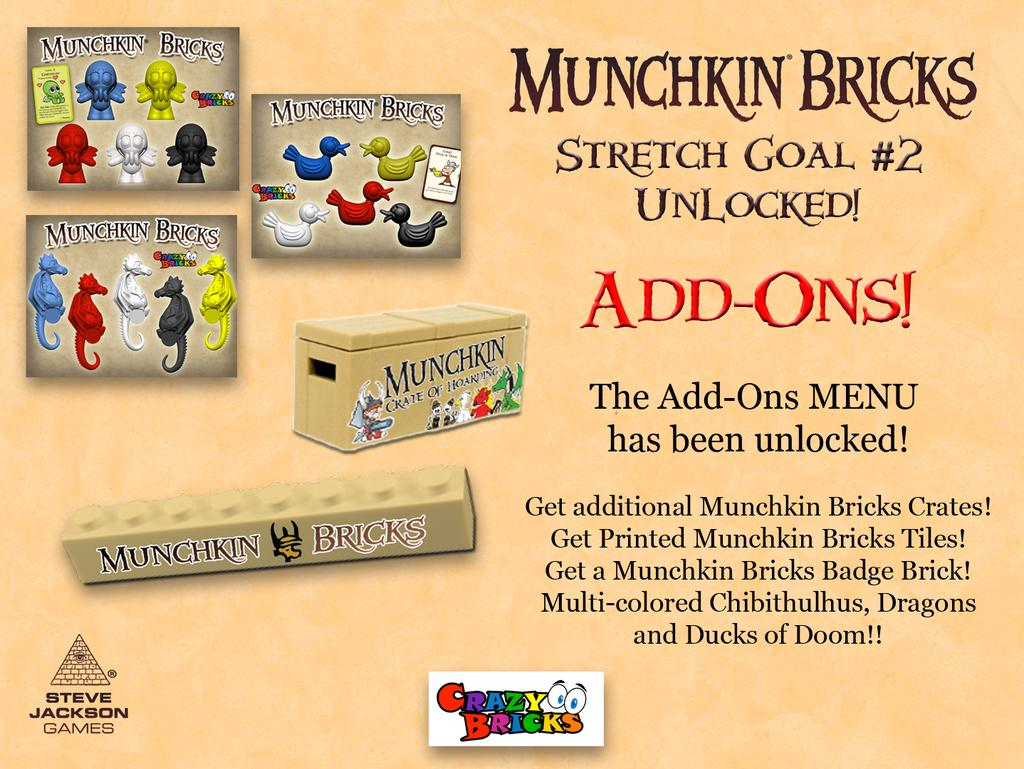<image>
Offer a succinct explanation of the picture presented. Some pictures advertising Munchkin Bricks add-ons and crazy bricks 